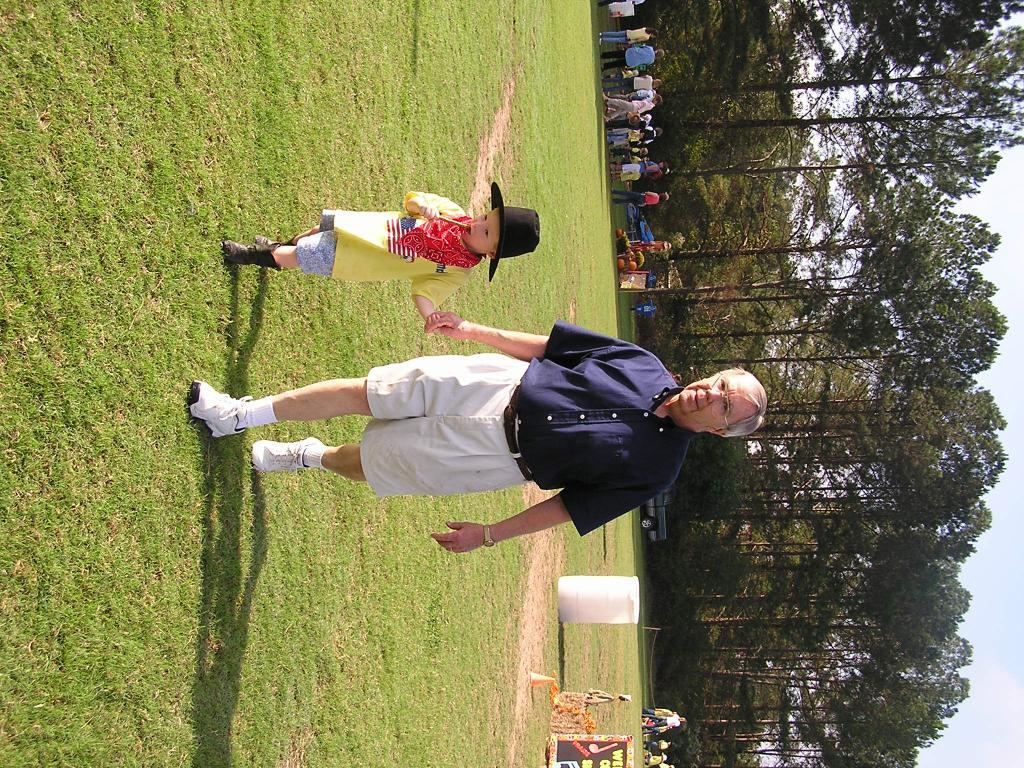What is the primary vegetation covering the land in the image? The land is covered with grass. What is the man in the image doing? The man is holding the hand of a boy. What is the boy wearing in the image? The boy is wearing a hat. Can you describe the background of the image? There are people, a board, trees, the sky, and other objects visible in the background. What is the distance between the people and the vehicle in the image? The vehicle is visible in the distance. How many wrens can be seen perched on the boy's hat in the image? There are no wrens visible on the boy's hat in the image. What type of finger movements are being demonstrated by the man in the image? There is no indication of finger movements being demonstrated by the man in the image. 